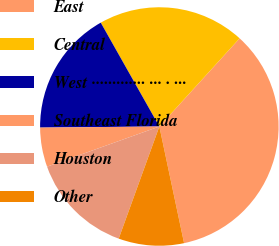Convert chart. <chart><loc_0><loc_0><loc_500><loc_500><pie_chart><fcel>East<fcel>Central<fcel>West ············· ··· · ···<fcel>Southeast Florida<fcel>Houston<fcel>Other<nl><fcel>34.92%<fcel>19.93%<fcel>16.97%<fcel>5.32%<fcel>14.0%<fcel>8.86%<nl></chart> 